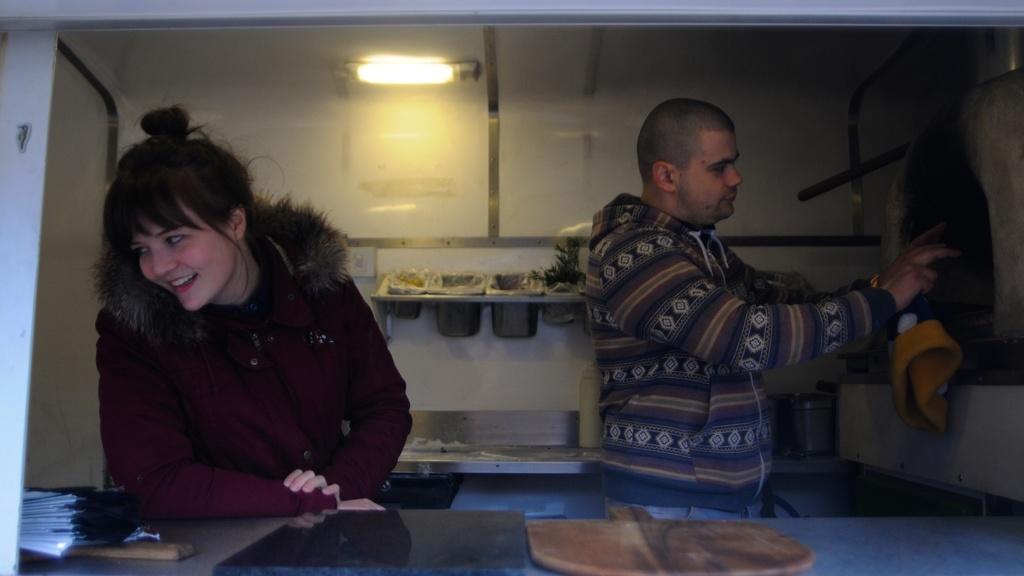How would you summarize this image in a sentence or two? This image clicked in a kitchen. There are two persons in this image. To the left, the woman is wearing brown jacket. In the front, there is a table on which some books, papers and wooden plate is kept. In the background, there is a wall and light. 